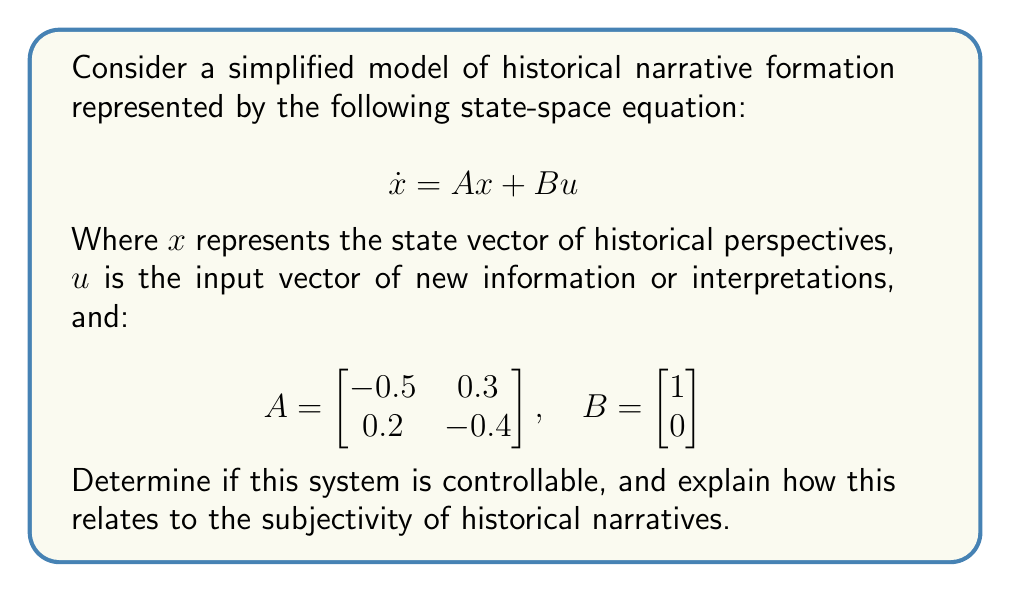What is the answer to this math problem? To determine the controllability of the system, we need to calculate the controllability matrix and check its rank. The controllability matrix is given by:

$$ C = [B \quad AB] $$

Step 1: Calculate AB
$$ AB = \begin{bmatrix} -0.5 & 0.3 \\ 0.2 & -0.4 \end{bmatrix} \begin{bmatrix} 1 \\ 0 \end{bmatrix} = \begin{bmatrix} -0.5 \\ 0.2 \end{bmatrix} $$

Step 2: Form the controllability matrix
$$ C = \begin{bmatrix} 1 & -0.5 \\ 0 & 0.2 \end{bmatrix} $$

Step 3: Calculate the determinant of C
$$ \det(C) = 1 \cdot 0.2 - (-0.5) \cdot 0 = 0.2 $$

Since the determinant is non-zero, the rank of C is 2, which is equal to the number of states in the system. Therefore, the system is controllable.

Interpretation: In the context of historical narratives, controllability suggests that it is possible to influence or "steer" the state of historical perspectives (x) through the introduction of new information or interpretations (u). This aligns with the philosophy major's argument that history is subjective and often biased, as it implies that historical narratives can be shaped or controlled by careful selection and presentation of information.

The controllability of the system indicates that, theoretically, any desired state of historical perspective can be reached from any initial state within finite time by applying appropriate inputs. This mathematical result supports the idea that historical narratives are not fixed or objective, but can be influenced and changed, reinforcing the subjective nature of historical study.
Answer: The system is controllable, supporting the subjectivity of historical narratives. 